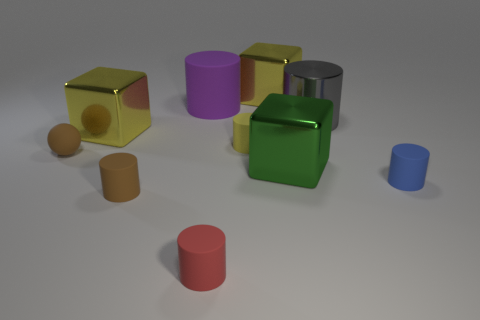There is a big purple object that is the same material as the brown sphere; what is its shape?
Ensure brevity in your answer.  Cylinder. What is the size of the rubber object that is the same color as the rubber sphere?
Make the answer very short. Small. Are there any tiny cylinders of the same color as the large matte object?
Offer a very short reply. No. The ball that is the same size as the blue rubber cylinder is what color?
Your answer should be compact. Brown. What number of yellow things are right of the metal cube left of the big purple cylinder?
Give a very brief answer. 2. What number of things are either big shiny objects on the left side of the green object or big purple rubber cylinders?
Offer a very short reply. 3. What number of yellow things have the same material as the green block?
Your answer should be very brief. 2. There is a tiny thing that is the same color as the sphere; what shape is it?
Your answer should be compact. Cylinder. Are there an equal number of small rubber cylinders on the left side of the green thing and shiny cylinders?
Provide a succinct answer. No. What is the size of the purple thing behind the ball?
Offer a terse response. Large. 